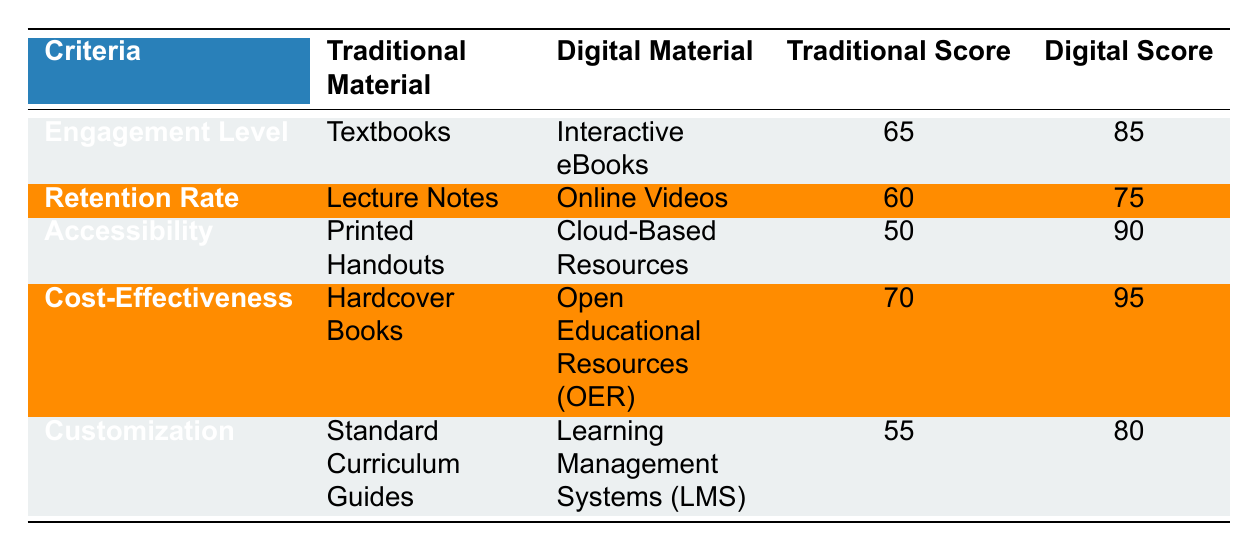What is the effectiveness score for digital materials in terms of engagement level? The table indicates that the effectiveness score for digital materials in the engagement level category is 85.
Answer: 85 What traditional material has a higher retention rate effectiveness score? The traditional material with a higher retention rate effectiveness score is Lecture Notes with a score of 60, compared to the digital material Online Videos which has a score of 75.
Answer: Lecture Notes What is the difference in effectiveness scores for accessibility between traditional and digital materials? The score for traditional material (Printed Handouts) is 50, and the digital material (Cloud-Based Resources) has a score of 90. The difference is 90 - 50 = 40.
Answer: 40 Do Open Educational Resources (OER) have a higher effectiveness score than hardcover books? Yes, Open Educational Resources (OER) have an effectiveness score of 95, which is higher than the score of 70 for hardcover books.
Answer: Yes What is the average effectiveness score for traditional materials? The traditional effectiveness scores are 65, 60, 50, 70, and 55. The sum of these scores is 400. Dividing by 5 gives the average: 400 / 5 = 80.
Answer: 80 What is the highest effectiveness score for digital materials in the table? The highest effectiveness score for digital materials is 95, which corresponds to Open Educational Resources (OER).
Answer: 95 Is there any category where the traditional effectiveness score surpasses the digital score? No, in all categories listed, the digital material's effectiveness score is higher than that of the traditional material.
Answer: No What is the total of the effectiveness scores for digital materials? The scores for digital materials are 85, 75, 90, 95, and 80. Summing these gives 85 + 75 + 90 + 95 + 80 = 425.
Answer: 425 What is the effectiveness score for traditional materials for customization? The effectiveness score for traditional materials in the customization category (Standard Curriculum Guides) is 55.
Answer: 55 